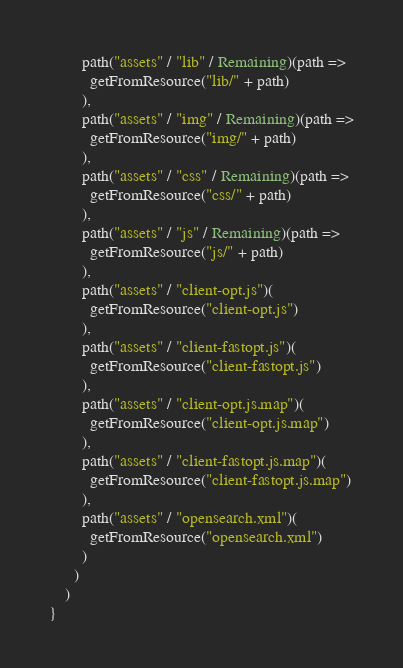<code> <loc_0><loc_0><loc_500><loc_500><_Scala_>        path("assets" / "lib" / Remaining)(path =>
          getFromResource("lib/" + path)
        ),
        path("assets" / "img" / Remaining)(path =>
          getFromResource("img/" + path)
        ),
        path("assets" / "css" / Remaining)(path =>
          getFromResource("css/" + path)
        ),
        path("assets" / "js" / Remaining)(path =>
          getFromResource("js/" + path)
        ),
        path("assets" / "client-opt.js")(
          getFromResource("client-opt.js")
        ),
        path("assets" / "client-fastopt.js")(
          getFromResource("client-fastopt.js")
        ),
        path("assets" / "client-opt.js.map")(
          getFromResource("client-opt.js.map")
        ),
        path("assets" / "client-fastopt.js.map")(
          getFromResource("client-fastopt.js.map")
        ),
        path("assets" / "opensearch.xml")(
          getFromResource("opensearch.xml")
        )
      )
    )
}
</code> 